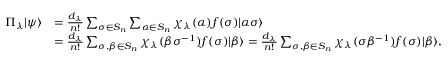<formula> <loc_0><loc_0><loc_500><loc_500>\begin{array} { r l } { \Pi _ { \lambda } | \psi \rangle } & { = \frac { d _ { \lambda } } { n ! } \sum _ { \sigma \in S _ { n } } \sum _ { \alpha \in S _ { n } } \chi _ { \lambda } ( \alpha ) f ( \sigma ) | \alpha \sigma \rangle } \\ & { = \frac { d _ { \lambda } } { n ! } \sum _ { \sigma , \beta \in S _ { n } } \chi _ { \lambda } ( \beta \sigma ^ { - 1 } ) f ( \sigma ) | \beta \rangle = \frac { d _ { \lambda } } { n ! } \sum _ { \sigma , \beta \in S _ { n } } \chi _ { \lambda } ( \sigma \beta ^ { - 1 } ) f ( \sigma ) | \beta \rangle , } \end{array}</formula> 